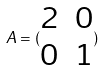Convert formula to latex. <formula><loc_0><loc_0><loc_500><loc_500>A = ( \begin{matrix} 2 & 0 \\ 0 & 1 \end{matrix} )</formula> 